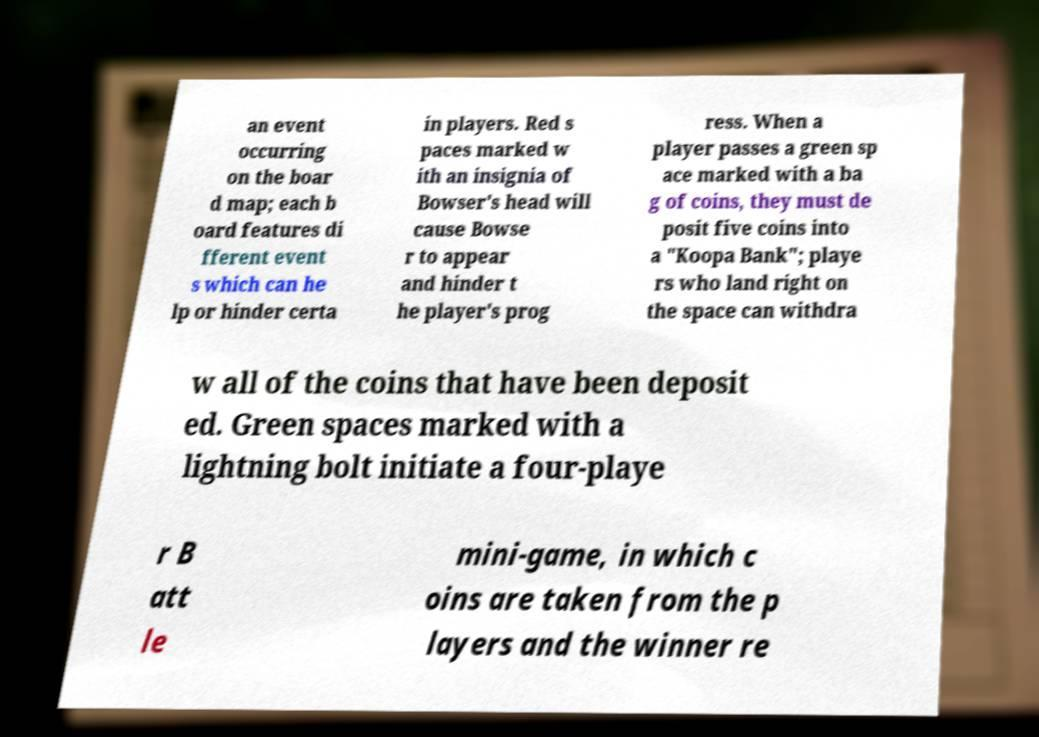For documentation purposes, I need the text within this image transcribed. Could you provide that? an event occurring on the boar d map; each b oard features di fferent event s which can he lp or hinder certa in players. Red s paces marked w ith an insignia of Bowser's head will cause Bowse r to appear and hinder t he player's prog ress. When a player passes a green sp ace marked with a ba g of coins, they must de posit five coins into a "Koopa Bank"; playe rs who land right on the space can withdra w all of the coins that have been deposit ed. Green spaces marked with a lightning bolt initiate a four-playe r B att le mini-game, in which c oins are taken from the p layers and the winner re 